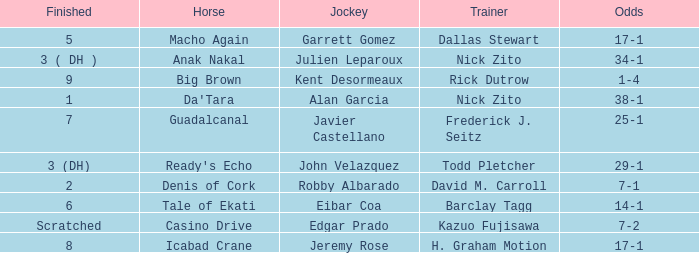Could you help me parse every detail presented in this table? {'header': ['Finished', 'Horse', 'Jockey', 'Trainer', 'Odds'], 'rows': [['5', 'Macho Again', 'Garrett Gomez', 'Dallas Stewart', '17-1'], ['3 ( DH )', 'Anak Nakal', 'Julien Leparoux', 'Nick Zito', '34-1'], ['9', 'Big Brown', 'Kent Desormeaux', 'Rick Dutrow', '1-4'], ['1', "Da'Tara", 'Alan Garcia', 'Nick Zito', '38-1'], ['7', 'Guadalcanal', 'Javier Castellano', 'Frederick J. Seitz', '25-1'], ['3 (DH)', "Ready's Echo", 'John Velazquez', 'Todd Pletcher', '29-1'], ['2', 'Denis of Cork', 'Robby Albarado', 'David M. Carroll', '7-1'], ['6', 'Tale of Ekati', 'Eibar Coa', 'Barclay Tagg', '14-1'], ['Scratched', 'Casino Drive', 'Edgar Prado', 'Kazuo Fujisawa', '7-2'], ['8', 'Icabad Crane', 'Jeremy Rose', 'H. Graham Motion', '17-1']]} Who is the Jockey for guadalcanal? Javier Castellano. 